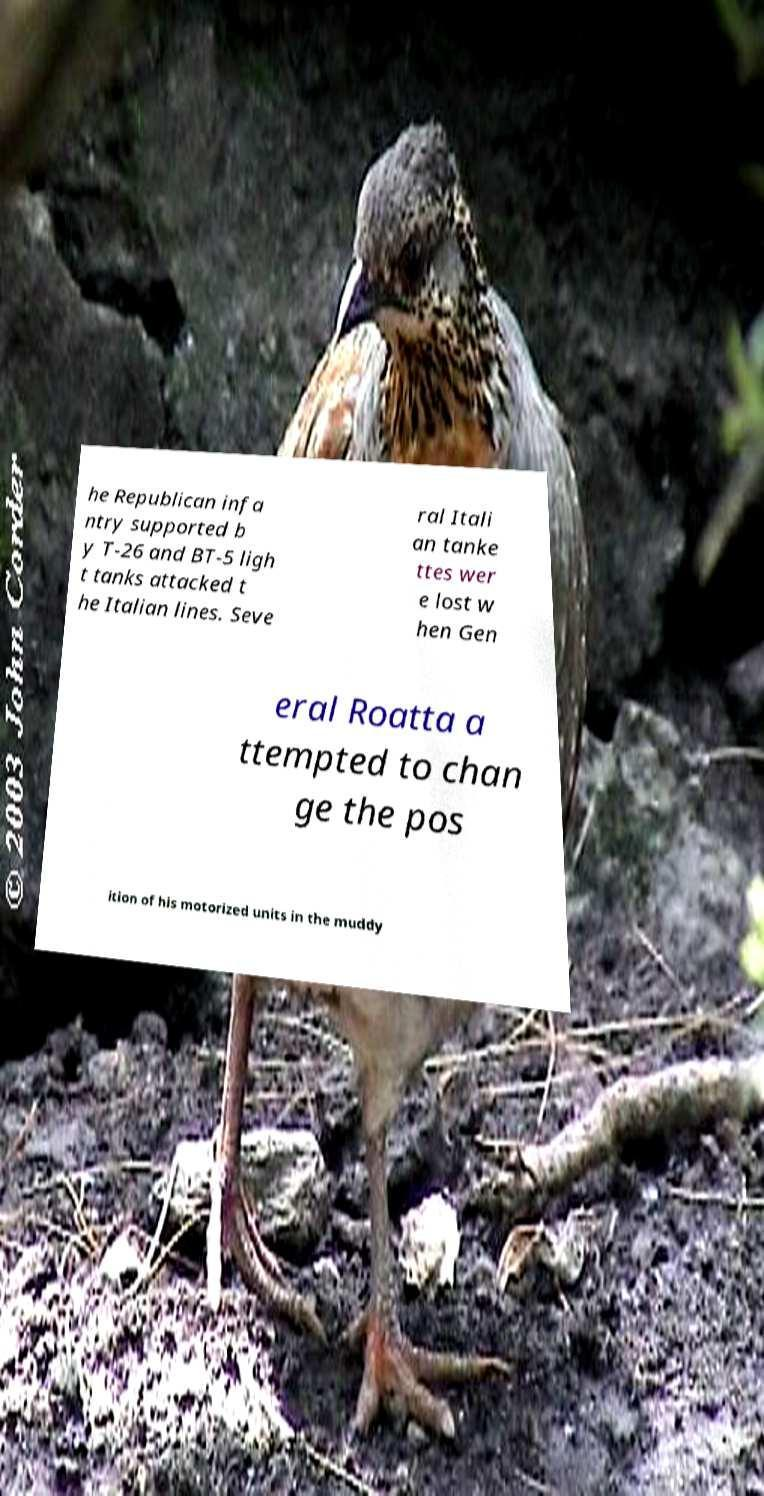What messages or text are displayed in this image? I need them in a readable, typed format. he Republican infa ntry supported b y T-26 and BT-5 ligh t tanks attacked t he Italian lines. Seve ral Itali an tanke ttes wer e lost w hen Gen eral Roatta a ttempted to chan ge the pos ition of his motorized units in the muddy 